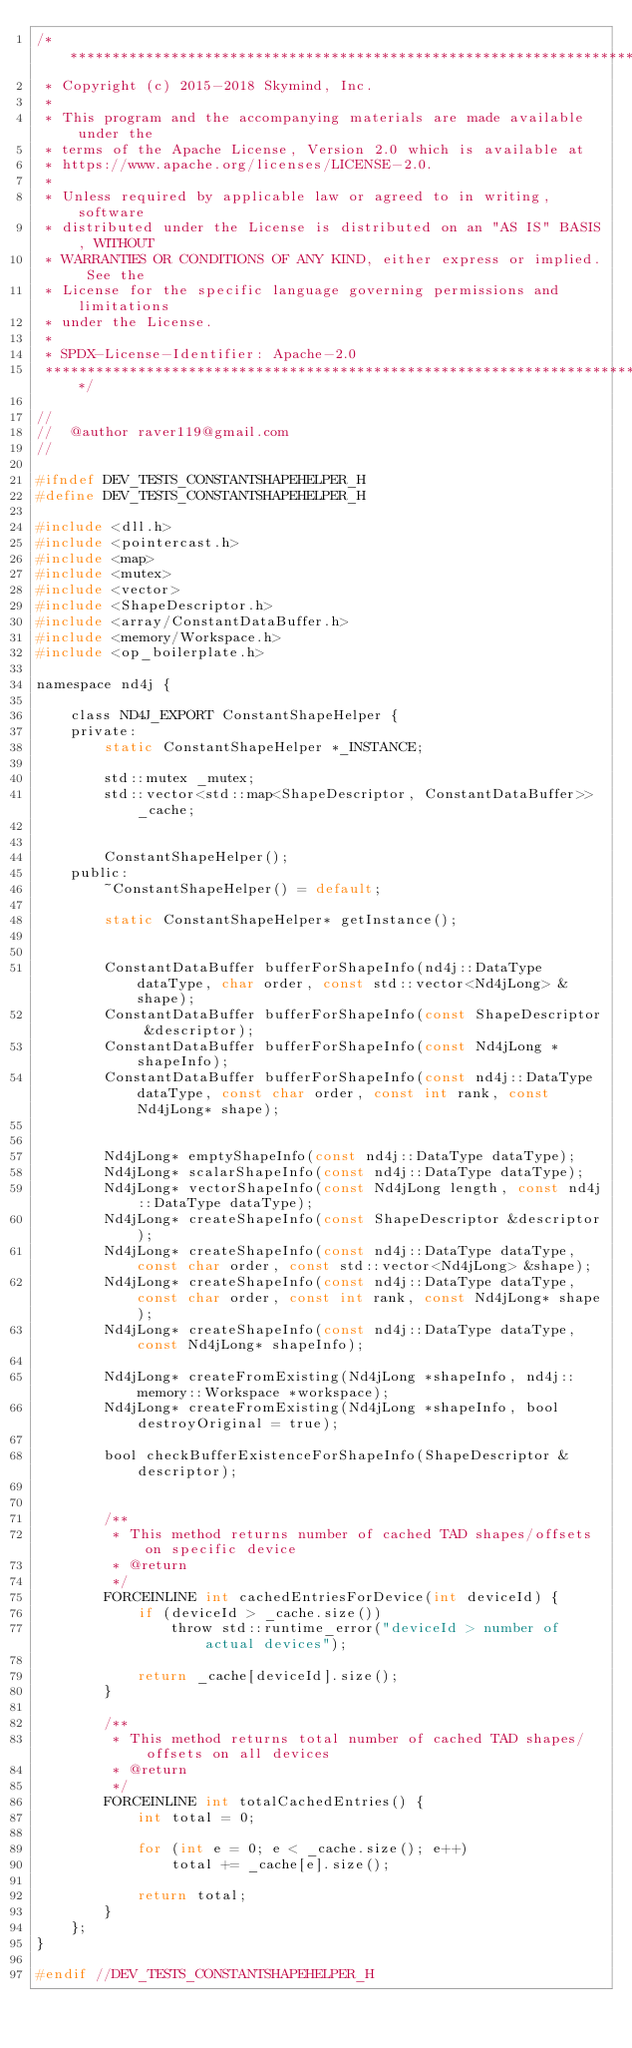Convert code to text. <code><loc_0><loc_0><loc_500><loc_500><_C_>/*******************************************************************************
 * Copyright (c) 2015-2018 Skymind, Inc.
 *
 * This program and the accompanying materials are made available under the
 * terms of the Apache License, Version 2.0 which is available at
 * https://www.apache.org/licenses/LICENSE-2.0.
 *
 * Unless required by applicable law or agreed to in writing, software
 * distributed under the License is distributed on an "AS IS" BASIS, WITHOUT
 * WARRANTIES OR CONDITIONS OF ANY KIND, either express or implied. See the
 * License for the specific language governing permissions and limitations
 * under the License.
 *
 * SPDX-License-Identifier: Apache-2.0
 ******************************************************************************/

//
//  @author raver119@gmail.com
//

#ifndef DEV_TESTS_CONSTANTSHAPEHELPER_H
#define DEV_TESTS_CONSTANTSHAPEHELPER_H

#include <dll.h>
#include <pointercast.h>
#include <map>
#include <mutex>
#include <vector>
#include <ShapeDescriptor.h>
#include <array/ConstantDataBuffer.h>
#include <memory/Workspace.h>
#include <op_boilerplate.h>

namespace nd4j {

    class ND4J_EXPORT ConstantShapeHelper {
    private:
        static ConstantShapeHelper *_INSTANCE;

        std::mutex _mutex;
        std::vector<std::map<ShapeDescriptor, ConstantDataBuffer>> _cache;


        ConstantShapeHelper();
    public:
        ~ConstantShapeHelper() = default;

        static ConstantShapeHelper* getInstance();


        ConstantDataBuffer bufferForShapeInfo(nd4j::DataType dataType, char order, const std::vector<Nd4jLong> &shape);
        ConstantDataBuffer bufferForShapeInfo(const ShapeDescriptor &descriptor);
        ConstantDataBuffer bufferForShapeInfo(const Nd4jLong *shapeInfo);
        ConstantDataBuffer bufferForShapeInfo(const nd4j::DataType dataType, const char order, const int rank, const Nd4jLong* shape);


        Nd4jLong* emptyShapeInfo(const nd4j::DataType dataType);
        Nd4jLong* scalarShapeInfo(const nd4j::DataType dataType);
        Nd4jLong* vectorShapeInfo(const Nd4jLong length, const nd4j::DataType dataType);
        Nd4jLong* createShapeInfo(const ShapeDescriptor &descriptor);
        Nd4jLong* createShapeInfo(const nd4j::DataType dataType, const char order, const std::vector<Nd4jLong> &shape);
        Nd4jLong* createShapeInfo(const nd4j::DataType dataType, const char order, const int rank, const Nd4jLong* shape);
        Nd4jLong* createShapeInfo(const nd4j::DataType dataType, const Nd4jLong* shapeInfo);

        Nd4jLong* createFromExisting(Nd4jLong *shapeInfo, nd4j::memory::Workspace *workspace);
        Nd4jLong* createFromExisting(Nd4jLong *shapeInfo, bool destroyOriginal = true);

        bool checkBufferExistenceForShapeInfo(ShapeDescriptor &descriptor);


        /**
         * This method returns number of cached TAD shapes/offsets on specific device
         * @return
         */
        FORCEINLINE int cachedEntriesForDevice(int deviceId) {
            if (deviceId > _cache.size())
                throw std::runtime_error("deviceId > number of actual devices");

            return _cache[deviceId].size();
        }

        /**
         * This method returns total number of cached TAD shapes/offsets on all devices
         * @return
         */
        FORCEINLINE int totalCachedEntries() {
            int total = 0;

            for (int e = 0; e < _cache.size(); e++)
                total += _cache[e].size();

            return total;
        }
    };
}

#endif //DEV_TESTS_CONSTANTSHAPEHELPER_H
</code> 